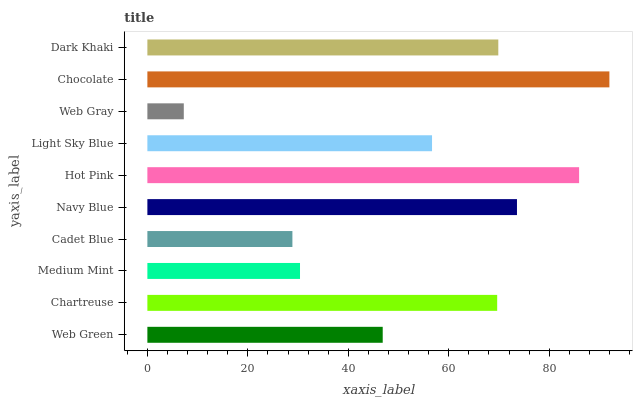Is Web Gray the minimum?
Answer yes or no. Yes. Is Chocolate the maximum?
Answer yes or no. Yes. Is Chartreuse the minimum?
Answer yes or no. No. Is Chartreuse the maximum?
Answer yes or no. No. Is Chartreuse greater than Web Green?
Answer yes or no. Yes. Is Web Green less than Chartreuse?
Answer yes or no. Yes. Is Web Green greater than Chartreuse?
Answer yes or no. No. Is Chartreuse less than Web Green?
Answer yes or no. No. Is Chartreuse the high median?
Answer yes or no. Yes. Is Light Sky Blue the low median?
Answer yes or no. Yes. Is Web Green the high median?
Answer yes or no. No. Is Dark Khaki the low median?
Answer yes or no. No. 